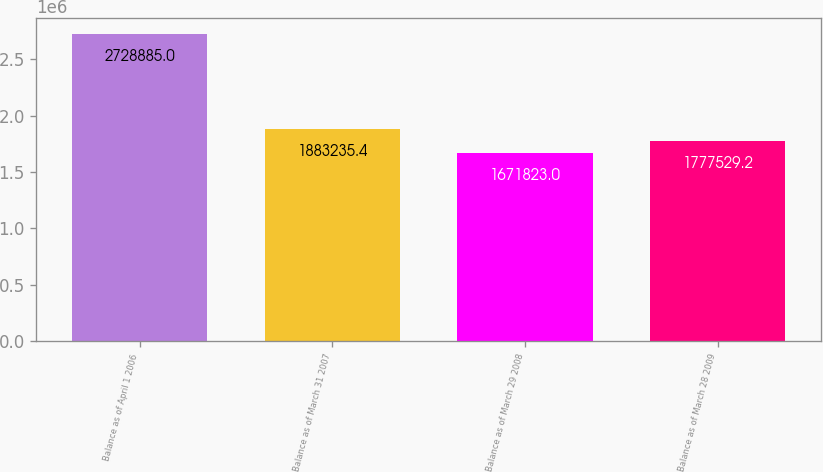Convert chart. <chart><loc_0><loc_0><loc_500><loc_500><bar_chart><fcel>Balance as of April 1 2006<fcel>Balance as of March 31 2007<fcel>Balance as of March 29 2008<fcel>Balance as of March 28 2009<nl><fcel>2.72888e+06<fcel>1.88324e+06<fcel>1.67182e+06<fcel>1.77753e+06<nl></chart> 